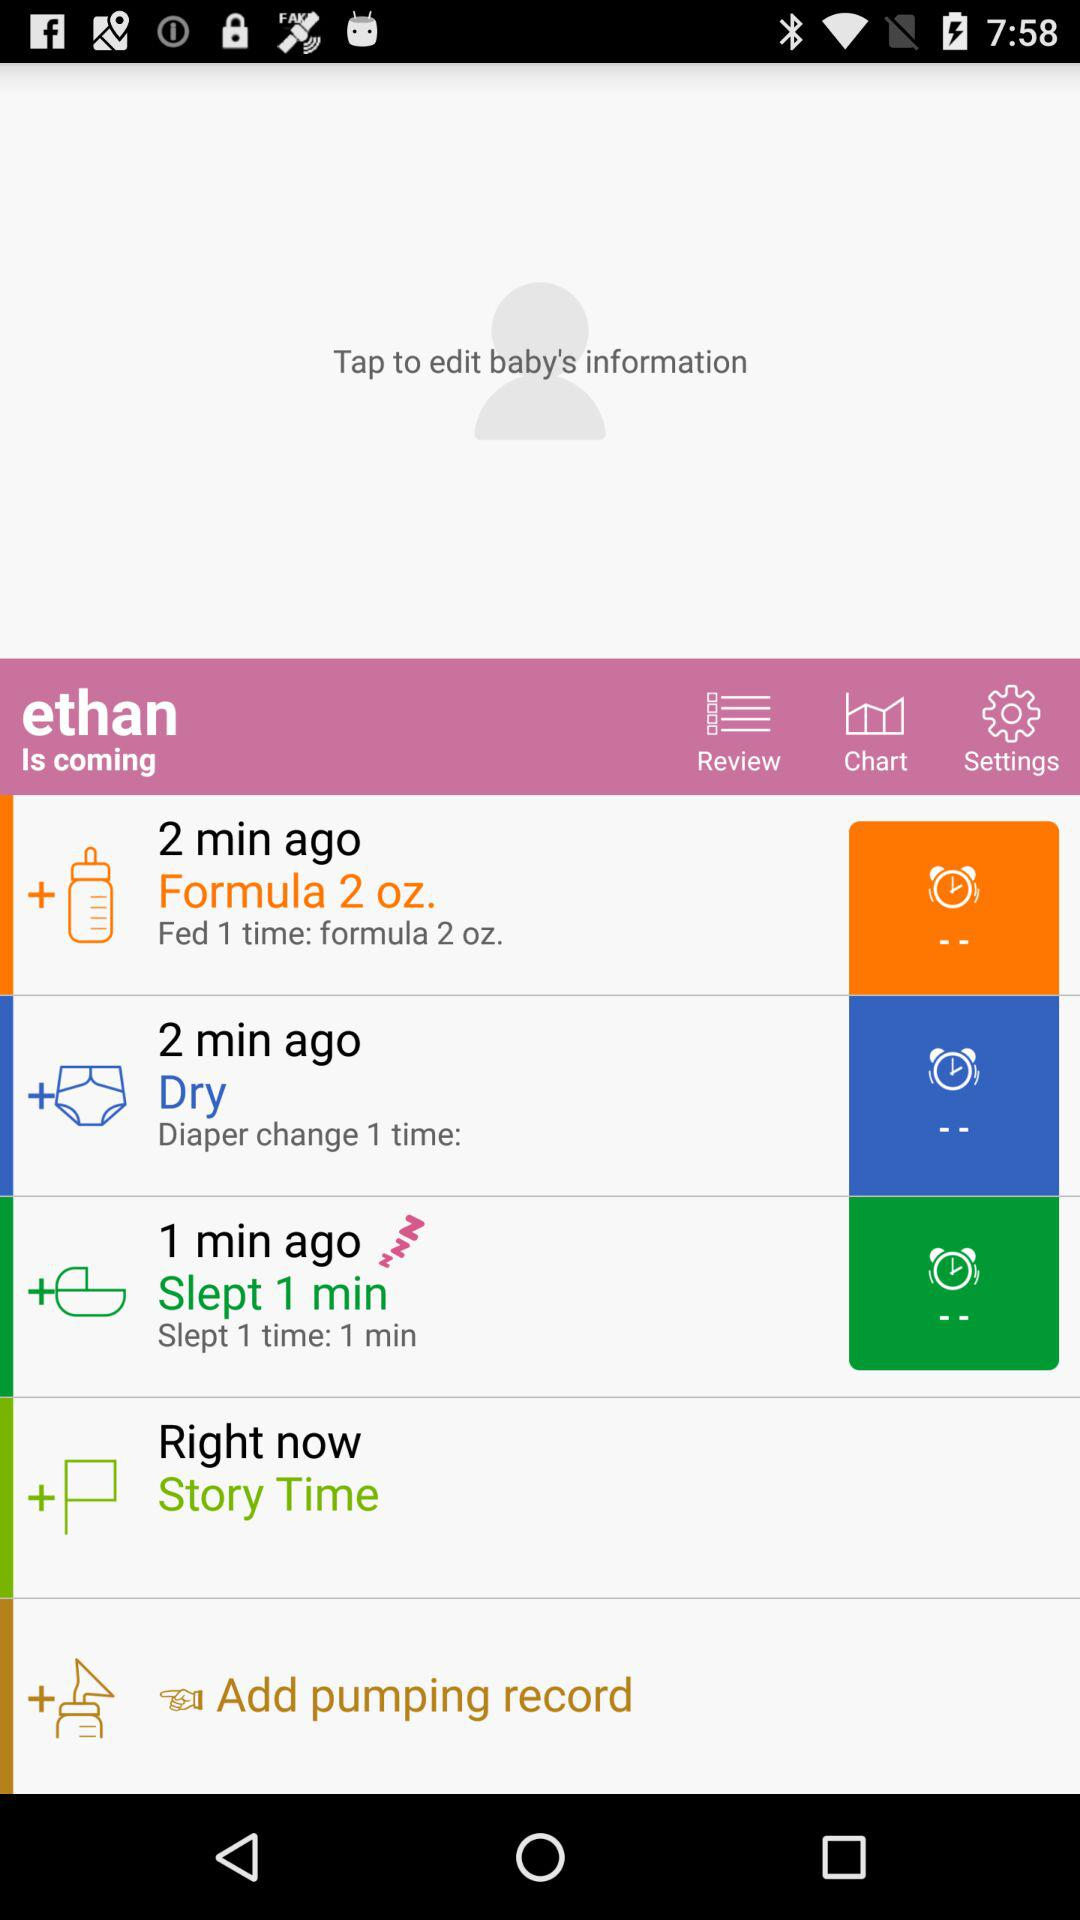How many minutes ago did the baby last sleep?
Answer the question using a single word or phrase. 1 